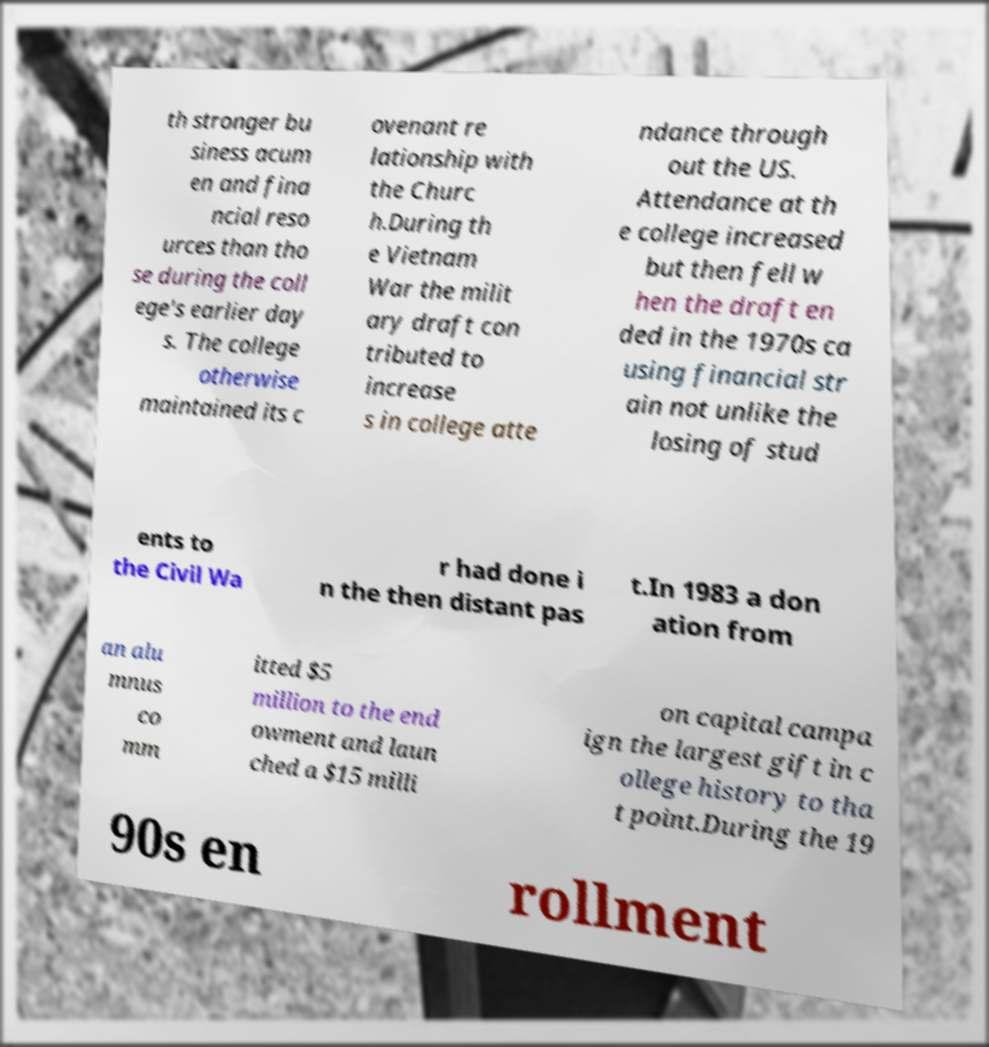For documentation purposes, I need the text within this image transcribed. Could you provide that? th stronger bu siness acum en and fina ncial reso urces than tho se during the coll ege's earlier day s. The college otherwise maintained its c ovenant re lationship with the Churc h.During th e Vietnam War the milit ary draft con tributed to increase s in college atte ndance through out the US. Attendance at th e college increased but then fell w hen the draft en ded in the 1970s ca using financial str ain not unlike the losing of stud ents to the Civil Wa r had done i n the then distant pas t.In 1983 a don ation from an alu mnus co mm itted $5 million to the end owment and laun ched a $15 milli on capital campa ign the largest gift in c ollege history to tha t point.During the 19 90s en rollment 